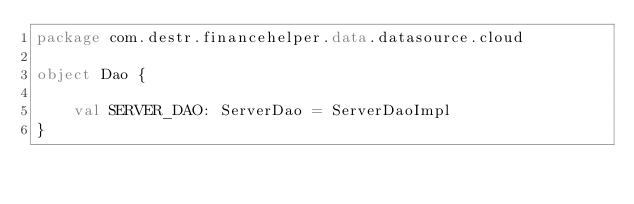<code> <loc_0><loc_0><loc_500><loc_500><_Kotlin_>package com.destr.financehelper.data.datasource.cloud

object Dao {

    val SERVER_DAO: ServerDao = ServerDaoImpl
}</code> 